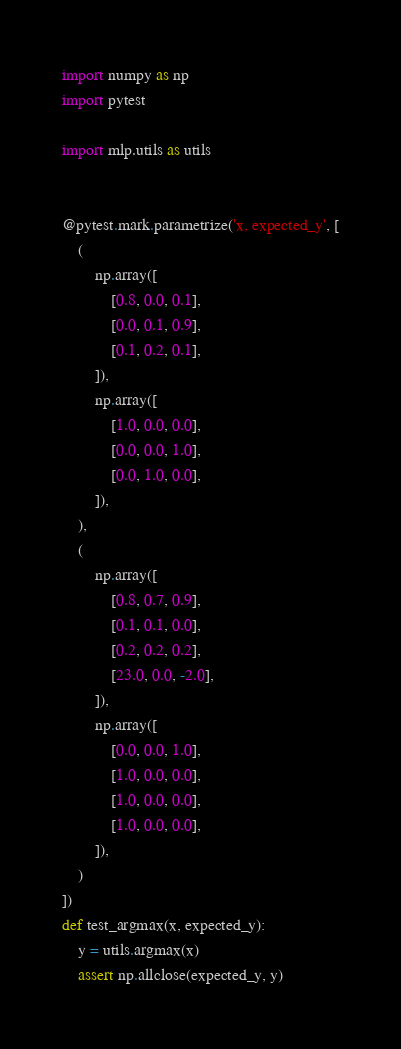<code> <loc_0><loc_0><loc_500><loc_500><_Python_>import numpy as np
import pytest

import mlp.utils as utils


@pytest.mark.parametrize('x, expected_y', [
    (
        np.array([
            [0.8, 0.0, 0.1],
            [0.0, 0.1, 0.9],
            [0.1, 0.2, 0.1],
        ]),
        np.array([
            [1.0, 0.0, 0.0],
            [0.0, 0.0, 1.0],
            [0.0, 1.0, 0.0],
        ]),
    ),
    (
        np.array([
            [0.8, 0.7, 0.9],
            [0.1, 0.1, 0.0],
            [0.2, 0.2, 0.2],
            [23.0, 0.0, -2.0],
        ]),
        np.array([
            [0.0, 0.0, 1.0],
            [1.0, 0.0, 0.0],
            [1.0, 0.0, 0.0],
            [1.0, 0.0, 0.0],
        ]),
    )
])
def test_argmax(x, expected_y):
    y = utils.argmax(x)
    assert np.allclose(expected_y, y)

</code> 